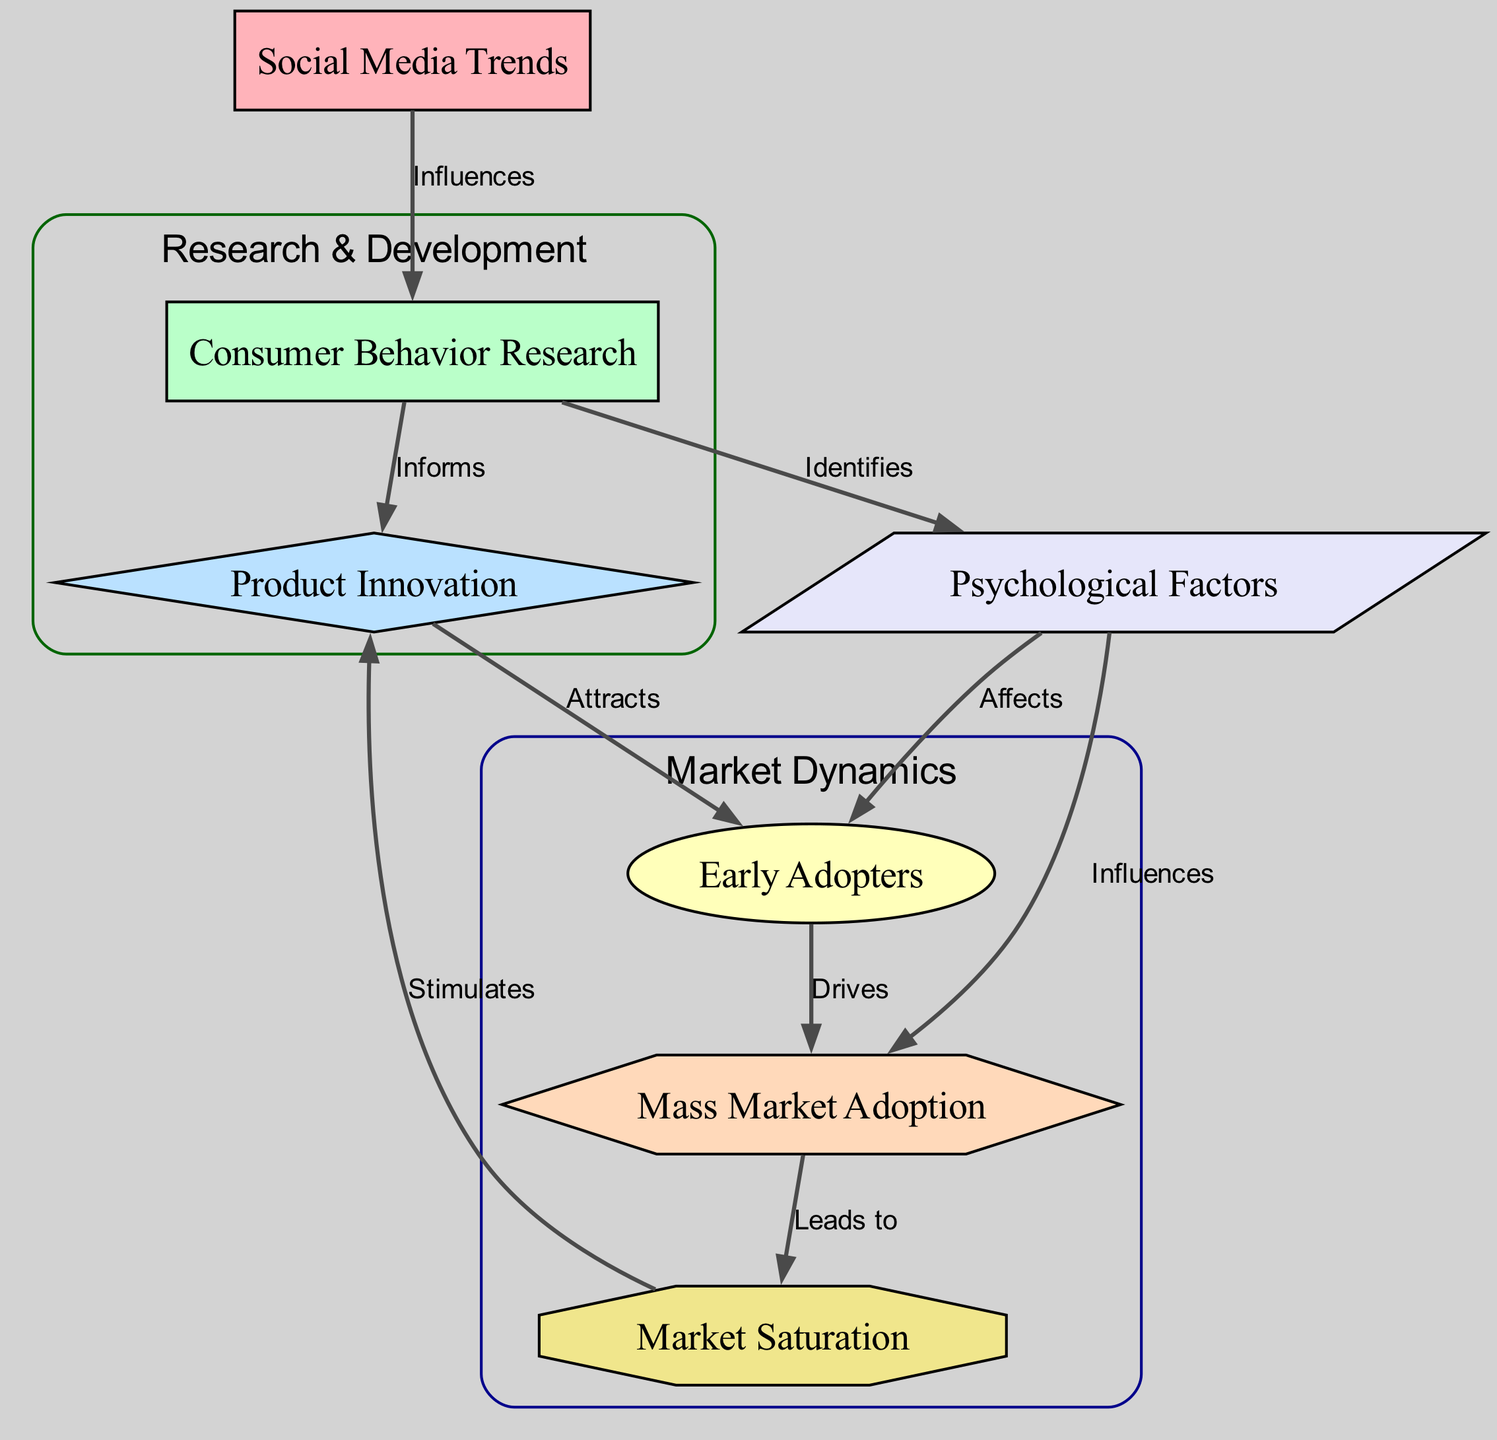What node influences Consumer Behavior Research? The diagram indicates that "Social Media Trends" is directly connected to "Consumer Behavior Research," showing an influence relationship.
Answer: Social Media Trends How many nodes are represented in the diagram? Counting all nodes listed, there are seven unique nodes present.
Answer: 7 What is the shape of the Product Innovation node? The diagram specifies that the "Product Innovation" node is represented as a diamond shape.
Answer: Diamond Which node is directly influenced by the Psychological Factors node? There are two nodes influenced by "Psychological Factors": "Early Adopters" and "Mass Market Adoption." Each has a direct edge indicating influence.
Answer: Early Adopters, Mass Market Adoption What does the edge between Consumer Behavior Research and Product Innovation represent? The edge labeled as "Informs" indicates that "Consumer Behavior Research" informs or contributes knowledge to "Product Innovation."
Answer: Informs How is Market Saturation stimulated? The diagram shows that "Market Saturation" is stimulated by the "Mass Market Adoption," indicating a feedback relationship where increased adoption leads to saturation.
Answer: Stimulated What role do Early Adopters play in the consumer adoption process? The diagram illustrates that "Early Adopters" drive the process of mass market adoption, acting as a catalyst for wider consumer acceptance.
Answer: Drives What affects Early Adopters, according to the diagram? The diagram specifies that "Psychological Factors" affect the adoption behavior of "Early Adopters," indicating a psychological component in their decision-making process.
Answer: Affects 